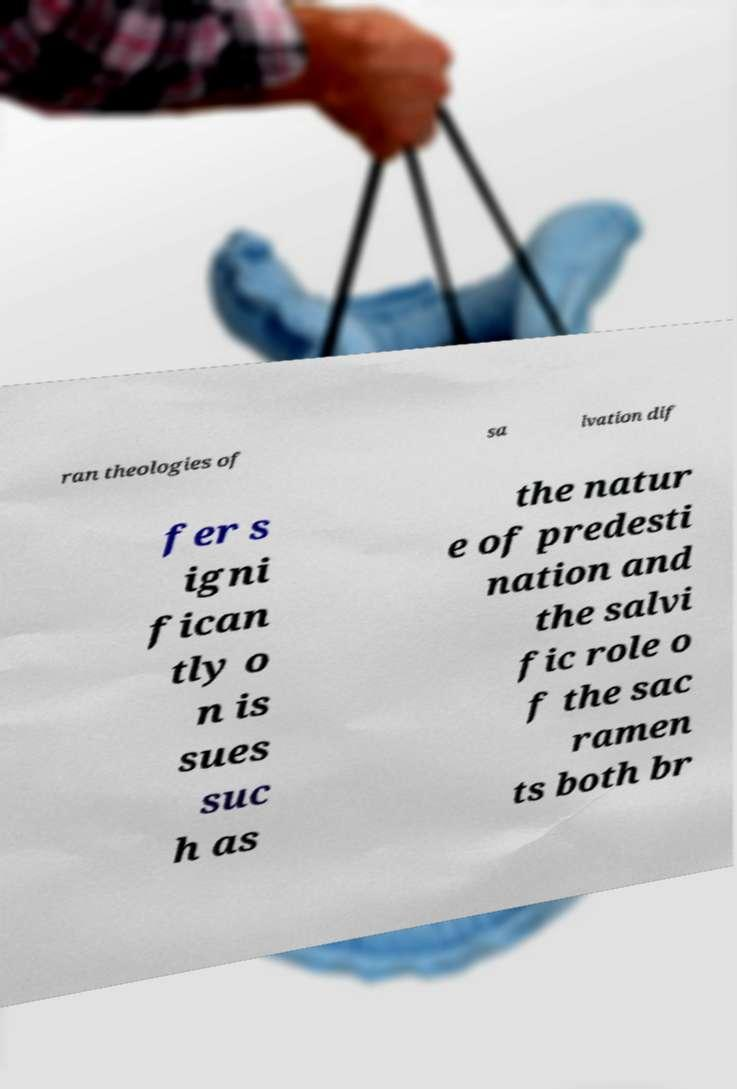Can you read and provide the text displayed in the image?This photo seems to have some interesting text. Can you extract and type it out for me? ran theologies of sa lvation dif fer s igni fican tly o n is sues suc h as the natur e of predesti nation and the salvi fic role o f the sac ramen ts both br 